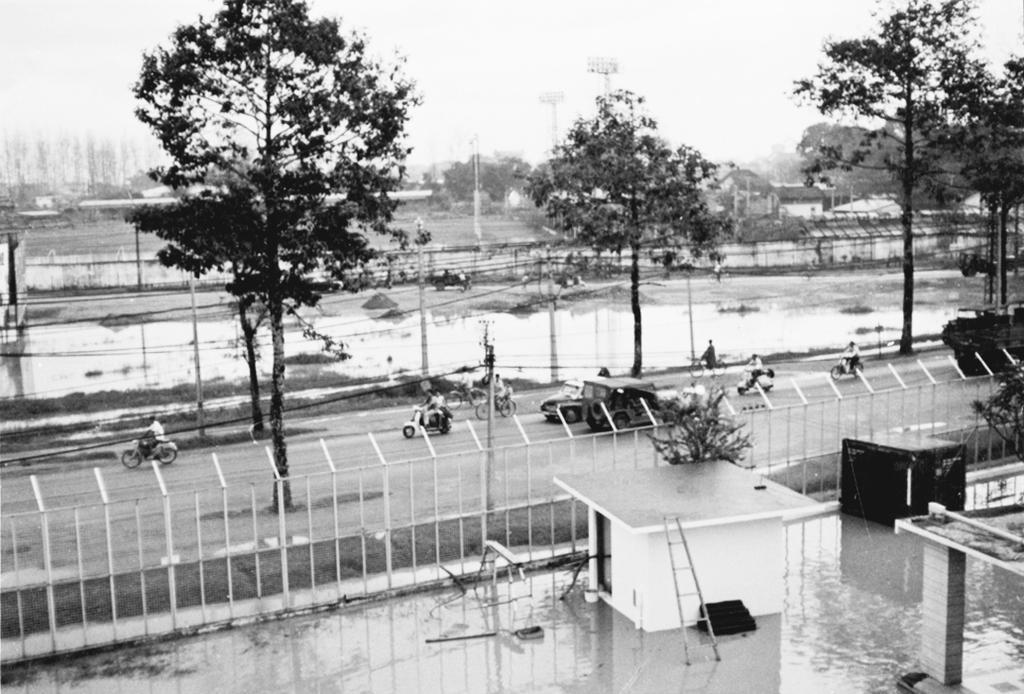Please provide a concise description of this image. In this black and white image there are few vehicles are moving on the road and there is a railing and a few tables and some other objects are on the floor. In the background there are trees, water and a sky. 